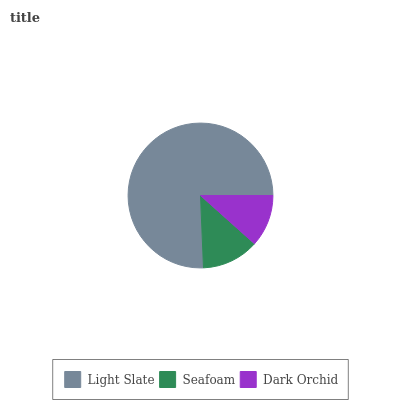Is Dark Orchid the minimum?
Answer yes or no. Yes. Is Light Slate the maximum?
Answer yes or no. Yes. Is Seafoam the minimum?
Answer yes or no. No. Is Seafoam the maximum?
Answer yes or no. No. Is Light Slate greater than Seafoam?
Answer yes or no. Yes. Is Seafoam less than Light Slate?
Answer yes or no. Yes. Is Seafoam greater than Light Slate?
Answer yes or no. No. Is Light Slate less than Seafoam?
Answer yes or no. No. Is Seafoam the high median?
Answer yes or no. Yes. Is Seafoam the low median?
Answer yes or no. Yes. Is Light Slate the high median?
Answer yes or no. No. Is Dark Orchid the low median?
Answer yes or no. No. 